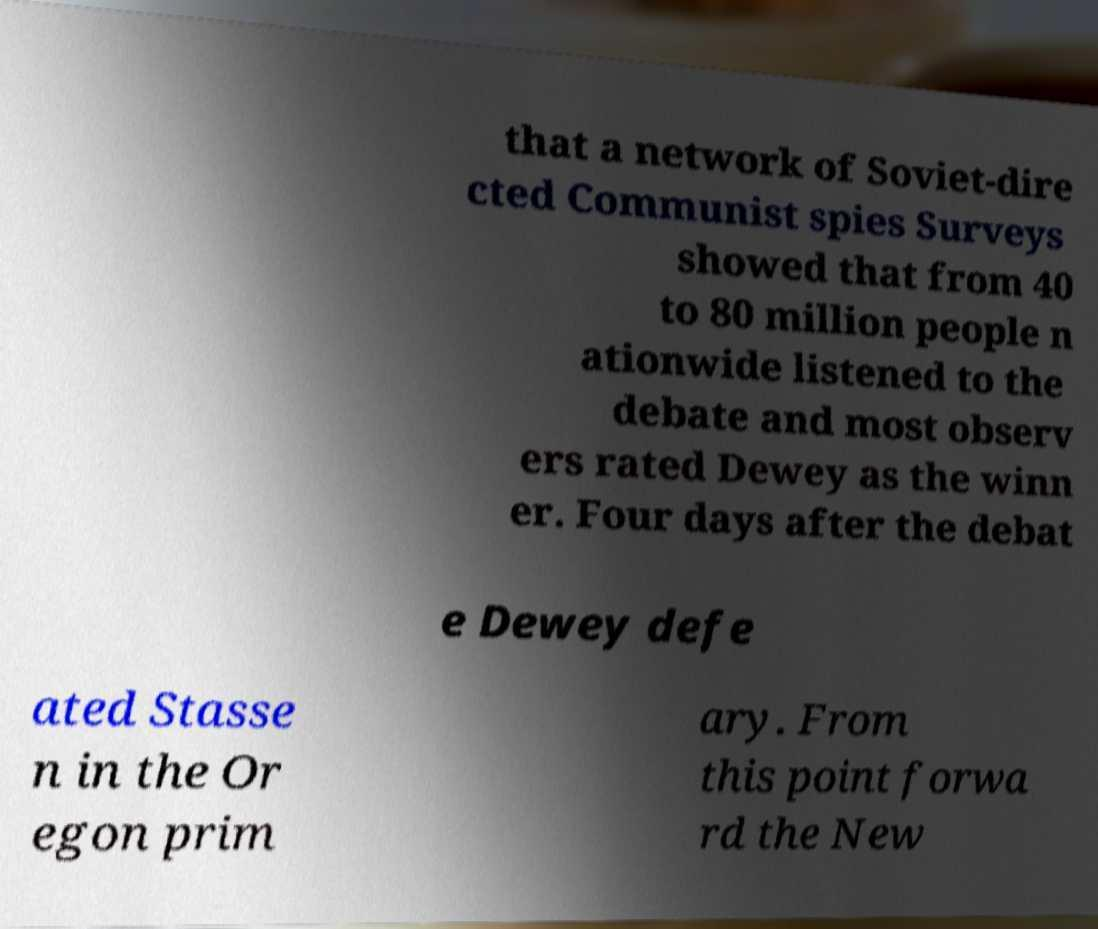Could you assist in decoding the text presented in this image and type it out clearly? that a network of Soviet-dire cted Communist spies Surveys showed that from 40 to 80 million people n ationwide listened to the debate and most observ ers rated Dewey as the winn er. Four days after the debat e Dewey defe ated Stasse n in the Or egon prim ary. From this point forwa rd the New 